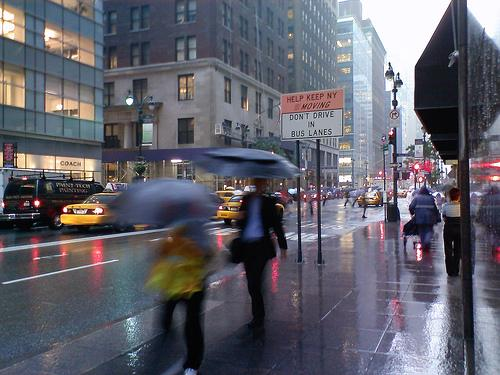How many people can be seen holding umbrellas and crossing the street in the image? Two people can be seen holding umbrellas and crossing the street in the image. Describe the interaction between pedestrians and the wet street in the picture. Pedestrians are walking quickly across the wet street, navigating their way through stopped vehicles and holding umbrellas to shield themselves from the rain. Provide a detailed description of the person with the yellow raincoat and umbrella. The person is wearing a yellow raincoat under an open umbrella, presumably walking or standing near the wet sidewalk, and is partly obscured, making it difficult to discern any other specific details. Explain the purpose of the orange and white sign in the image. The orange and white sign is a road sign meant to help keep traffic steady and maintain order on the busy street. Count the total number of vehicles present in the image and specify their types. There are a total of four vehicles in the image: a green van, a black van, a yellow taxi cab, and a car. Analyze the emotions/feelings associated with this image. The image portrays a sense of urgency, rush, and inconvenience due to wet weather conditions and slowed or stopped traffic in an urban setting. What is the most prominent color in the entire image? Green is the most prominent color in the entire image due to the presence of tall buildings, a black van, and a green van on the street. Please rate the overall quality of the image from 1 to 10, with 10 being the highest quality. Based on the details provided, the image quality can be rated at 8, showing a clear depiction of objects and their interactions in the scene. Please provide a brief description of the scene captured in this image. The image depicts a busy, wet street in a city with pedestrians walking quickly, some holding umbrellas, slowed or stopped traffic, and street signs and lights. Identify the two primary objects in the bottom left corner of the image and describe their appearance. The primary objects are a green van and a black van on the road, both with visible brake lights indicating they are stopped or moving slowly. Observe the group of jumping dolphins in the middle of the road, next to the stopped traffic. No, it's not mentioned in the image. Describe the appearance of the person walking under the umbrella. A person wearing yellow raincoat, holding a black umbrella Compose a brief and imaginative story about the wet day in the image. On a rainy day in the bustling city, people rushed, their colorful umbrellas painting the streets with life. Amidst the chaos, a mysterious figure in a yellow raincoat and a black umbrella made their way through the city. As the rain fell, a sense of adventure and intrigue filled the air. Is the light on the tall street light on or off? Off How many street lights are on the sidewalk, and which is on and off? Two street lights, one is on and one is off. Describe the silhouette of the sign. The sign is rectangular. What does the stop light display in the image? Red light What color are the brake lights of the car in the image? Red What action is happening around the person by the road with the black umbrella? People crossing wet street, walking very fast What type of vehicle is stopped on the road? A green van and a yellow taxi cab Identify the main event happening in the street. People crossing wet street Describe the condition of the sidewalk seen in the image. The sidewalk is wet. Create an advertisement slogan about the black umbrella displayed in the image. Withstand the storm, embrace the rain - the black umbrella, your perfect companion. Does this image show pedestrians walking very fast on the sidewalk or casually strolling? Walking very fast Analyze the layout of the buildings in the image. Tall buildings on the left with wide windows Find and read the text printed on the orange and white sign. Not enough information provided, content of the sign not specified. Choose the most accurate statement: A. People are walking slowly across the street. B. Pedestrians are walking quickly across the street. C. A couple is holding hands across the street. D. A dog is walking across the street. B. Pedestrians are walking quickly across the street. State the color of the umbrella in the image. Black What color is the raincoat that the person is wearing under the umbrella? Yellow Create a short poem about the scene depicted in the image. Rain-soaked streets, city alive, 